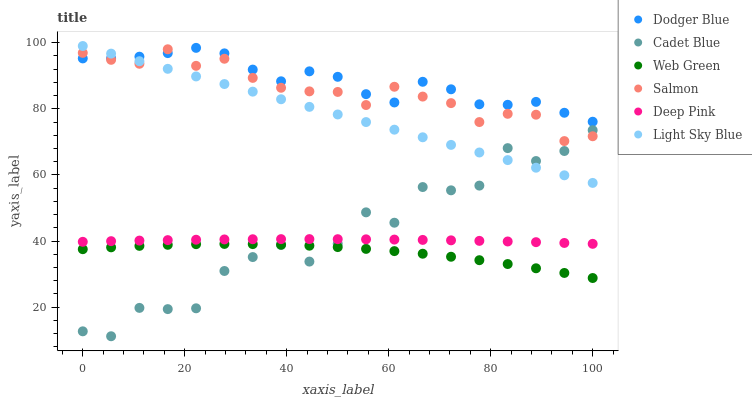Does Web Green have the minimum area under the curve?
Answer yes or no. Yes. Does Dodger Blue have the maximum area under the curve?
Answer yes or no. Yes. Does Deep Pink have the minimum area under the curve?
Answer yes or no. No. Does Deep Pink have the maximum area under the curve?
Answer yes or no. No. Is Light Sky Blue the smoothest?
Answer yes or no. Yes. Is Cadet Blue the roughest?
Answer yes or no. Yes. Is Deep Pink the smoothest?
Answer yes or no. No. Is Deep Pink the roughest?
Answer yes or no. No. Does Cadet Blue have the lowest value?
Answer yes or no. Yes. Does Deep Pink have the lowest value?
Answer yes or no. No. Does Light Sky Blue have the highest value?
Answer yes or no. Yes. Does Deep Pink have the highest value?
Answer yes or no. No. Is Web Green less than Deep Pink?
Answer yes or no. Yes. Is Dodger Blue greater than Deep Pink?
Answer yes or no. Yes. Does Web Green intersect Cadet Blue?
Answer yes or no. Yes. Is Web Green less than Cadet Blue?
Answer yes or no. No. Is Web Green greater than Cadet Blue?
Answer yes or no. No. Does Web Green intersect Deep Pink?
Answer yes or no. No. 